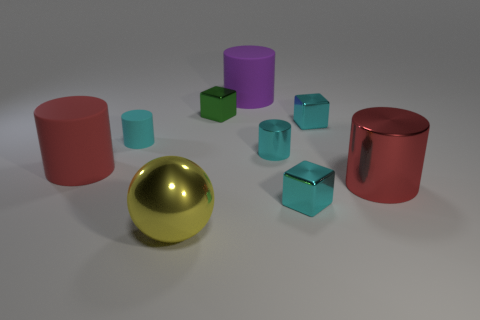What number of things are either red things left of the purple rubber object or large cyan balls?
Your answer should be very brief. 1. There is a cyan cylinder that is right of the small rubber thing; what number of spheres are behind it?
Your answer should be very brief. 0. There is a cylinder that is in front of the big red object that is left of the tiny metallic cube left of the purple cylinder; how big is it?
Provide a succinct answer. Large. There is a large matte thing on the right side of the big red matte object; is it the same color as the large metal cylinder?
Ensure brevity in your answer.  No. What is the size of the red matte object that is the same shape as the purple rubber object?
Your response must be concise. Large. What number of objects are tiny metal objects that are left of the purple cylinder or cyan things left of the green block?
Your answer should be very brief. 2. There is a large red thing right of the cyan metallic cylinder in front of the small cyan rubber object; what shape is it?
Provide a short and direct response. Cylinder. Are there any other things that are the same color as the large sphere?
Keep it short and to the point. No. Is there anything else that is the same size as the yellow metallic object?
Give a very brief answer. Yes. How many objects are either tiny green blocks or tiny cyan blocks?
Your answer should be very brief. 3. 